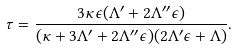<formula> <loc_0><loc_0><loc_500><loc_500>\tau = \frac { 3 \kappa \epsilon ( \Lambda ^ { \prime } + 2 \Lambda ^ { \prime \prime } \epsilon ) } { ( \kappa + 3 \Lambda ^ { \prime } + 2 \Lambda ^ { \prime \prime } \epsilon ) ( 2 \Lambda ^ { \prime } \epsilon + \Lambda ) } .</formula> 